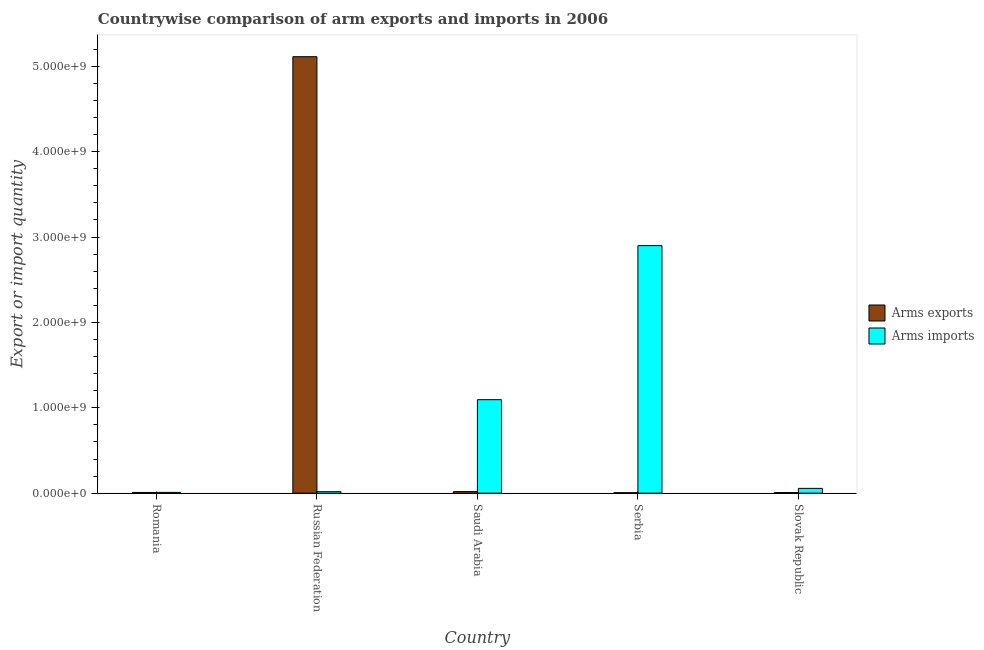How many different coloured bars are there?
Your response must be concise. 2. Are the number of bars on each tick of the X-axis equal?
Make the answer very short. Yes. How many bars are there on the 3rd tick from the left?
Provide a short and direct response. 2. What is the label of the 1st group of bars from the left?
Ensure brevity in your answer.  Romania. What is the arms imports in Serbia?
Provide a succinct answer. 2.90e+09. Across all countries, what is the maximum arms imports?
Give a very brief answer. 2.90e+09. Across all countries, what is the minimum arms exports?
Ensure brevity in your answer.  5.00e+06. In which country was the arms imports maximum?
Your answer should be compact. Serbia. In which country was the arms exports minimum?
Your response must be concise. Serbia. What is the total arms imports in the graph?
Your answer should be compact. 4.08e+09. What is the difference between the arms exports in Romania and that in Russian Federation?
Your answer should be compact. -5.10e+09. What is the difference between the arms exports in Romania and the arms imports in Russian Federation?
Provide a short and direct response. -9.00e+06. What is the average arms imports per country?
Keep it short and to the point. 8.15e+08. What is the difference between the arms exports and arms imports in Slovak Republic?
Provide a short and direct response. -4.90e+07. In how many countries, is the arms imports greater than 400000000 ?
Your answer should be compact. 2. What is the ratio of the arms imports in Serbia to that in Slovak Republic?
Your answer should be compact. 51.79. What is the difference between the highest and the second highest arms imports?
Offer a terse response. 1.80e+09. What is the difference between the highest and the lowest arms imports?
Your response must be concise. 2.89e+09. In how many countries, is the arms imports greater than the average arms imports taken over all countries?
Ensure brevity in your answer.  2. Is the sum of the arms exports in Romania and Slovak Republic greater than the maximum arms imports across all countries?
Give a very brief answer. No. What does the 1st bar from the left in Serbia represents?
Offer a terse response. Arms exports. What does the 2nd bar from the right in Romania represents?
Your answer should be compact. Arms exports. How many bars are there?
Offer a terse response. 10. How many countries are there in the graph?
Give a very brief answer. 5. What is the difference between two consecutive major ticks on the Y-axis?
Your answer should be compact. 1.00e+09. Where does the legend appear in the graph?
Give a very brief answer. Center right. How many legend labels are there?
Provide a succinct answer. 2. How are the legend labels stacked?
Provide a short and direct response. Vertical. What is the title of the graph?
Make the answer very short. Countrywise comparison of arm exports and imports in 2006. What is the label or title of the X-axis?
Provide a short and direct response. Country. What is the label or title of the Y-axis?
Offer a terse response. Export or import quantity. What is the Export or import quantity in Arms imports in Romania?
Keep it short and to the point. 9.00e+06. What is the Export or import quantity of Arms exports in Russian Federation?
Provide a short and direct response. 5.11e+09. What is the Export or import quantity of Arms imports in Russian Federation?
Offer a very short reply. 1.70e+07. What is the Export or import quantity in Arms exports in Saudi Arabia?
Offer a very short reply. 1.80e+07. What is the Export or import quantity in Arms imports in Saudi Arabia?
Give a very brief answer. 1.10e+09. What is the Export or import quantity of Arms imports in Serbia?
Offer a very short reply. 2.90e+09. What is the Export or import quantity of Arms exports in Slovak Republic?
Your response must be concise. 7.00e+06. What is the Export or import quantity of Arms imports in Slovak Republic?
Provide a short and direct response. 5.60e+07. Across all countries, what is the maximum Export or import quantity of Arms exports?
Provide a short and direct response. 5.11e+09. Across all countries, what is the maximum Export or import quantity in Arms imports?
Your answer should be very brief. 2.90e+09. Across all countries, what is the minimum Export or import quantity of Arms imports?
Offer a terse response. 9.00e+06. What is the total Export or import quantity of Arms exports in the graph?
Keep it short and to the point. 5.15e+09. What is the total Export or import quantity of Arms imports in the graph?
Your answer should be compact. 4.08e+09. What is the difference between the Export or import quantity in Arms exports in Romania and that in Russian Federation?
Provide a short and direct response. -5.10e+09. What is the difference between the Export or import quantity of Arms imports in Romania and that in Russian Federation?
Your answer should be compact. -8.00e+06. What is the difference between the Export or import quantity of Arms exports in Romania and that in Saudi Arabia?
Ensure brevity in your answer.  -1.00e+07. What is the difference between the Export or import quantity in Arms imports in Romania and that in Saudi Arabia?
Your answer should be very brief. -1.09e+09. What is the difference between the Export or import quantity in Arms exports in Romania and that in Serbia?
Offer a very short reply. 3.00e+06. What is the difference between the Export or import quantity of Arms imports in Romania and that in Serbia?
Your response must be concise. -2.89e+09. What is the difference between the Export or import quantity in Arms imports in Romania and that in Slovak Republic?
Your answer should be very brief. -4.70e+07. What is the difference between the Export or import quantity in Arms exports in Russian Federation and that in Saudi Arabia?
Ensure brevity in your answer.  5.10e+09. What is the difference between the Export or import quantity of Arms imports in Russian Federation and that in Saudi Arabia?
Provide a succinct answer. -1.08e+09. What is the difference between the Export or import quantity in Arms exports in Russian Federation and that in Serbia?
Provide a succinct answer. 5.11e+09. What is the difference between the Export or import quantity in Arms imports in Russian Federation and that in Serbia?
Ensure brevity in your answer.  -2.88e+09. What is the difference between the Export or import quantity of Arms exports in Russian Federation and that in Slovak Republic?
Provide a succinct answer. 5.11e+09. What is the difference between the Export or import quantity in Arms imports in Russian Federation and that in Slovak Republic?
Offer a very short reply. -3.90e+07. What is the difference between the Export or import quantity in Arms exports in Saudi Arabia and that in Serbia?
Provide a succinct answer. 1.30e+07. What is the difference between the Export or import quantity of Arms imports in Saudi Arabia and that in Serbia?
Make the answer very short. -1.80e+09. What is the difference between the Export or import quantity in Arms exports in Saudi Arabia and that in Slovak Republic?
Your response must be concise. 1.10e+07. What is the difference between the Export or import quantity in Arms imports in Saudi Arabia and that in Slovak Republic?
Ensure brevity in your answer.  1.04e+09. What is the difference between the Export or import quantity of Arms exports in Serbia and that in Slovak Republic?
Make the answer very short. -2.00e+06. What is the difference between the Export or import quantity in Arms imports in Serbia and that in Slovak Republic?
Provide a short and direct response. 2.84e+09. What is the difference between the Export or import quantity of Arms exports in Romania and the Export or import quantity of Arms imports in Russian Federation?
Your answer should be very brief. -9.00e+06. What is the difference between the Export or import quantity of Arms exports in Romania and the Export or import quantity of Arms imports in Saudi Arabia?
Give a very brief answer. -1.09e+09. What is the difference between the Export or import quantity of Arms exports in Romania and the Export or import quantity of Arms imports in Serbia?
Provide a succinct answer. -2.89e+09. What is the difference between the Export or import quantity of Arms exports in Romania and the Export or import quantity of Arms imports in Slovak Republic?
Provide a succinct answer. -4.80e+07. What is the difference between the Export or import quantity of Arms exports in Russian Federation and the Export or import quantity of Arms imports in Saudi Arabia?
Provide a succinct answer. 4.02e+09. What is the difference between the Export or import quantity in Arms exports in Russian Federation and the Export or import quantity in Arms imports in Serbia?
Give a very brief answer. 2.21e+09. What is the difference between the Export or import quantity in Arms exports in Russian Federation and the Export or import quantity in Arms imports in Slovak Republic?
Make the answer very short. 5.06e+09. What is the difference between the Export or import quantity of Arms exports in Saudi Arabia and the Export or import quantity of Arms imports in Serbia?
Your answer should be very brief. -2.88e+09. What is the difference between the Export or import quantity in Arms exports in Saudi Arabia and the Export or import quantity in Arms imports in Slovak Republic?
Provide a succinct answer. -3.80e+07. What is the difference between the Export or import quantity of Arms exports in Serbia and the Export or import quantity of Arms imports in Slovak Republic?
Make the answer very short. -5.10e+07. What is the average Export or import quantity of Arms exports per country?
Give a very brief answer. 1.03e+09. What is the average Export or import quantity of Arms imports per country?
Offer a terse response. 8.15e+08. What is the difference between the Export or import quantity in Arms exports and Export or import quantity in Arms imports in Romania?
Ensure brevity in your answer.  -1.00e+06. What is the difference between the Export or import quantity of Arms exports and Export or import quantity of Arms imports in Russian Federation?
Give a very brief answer. 5.10e+09. What is the difference between the Export or import quantity in Arms exports and Export or import quantity in Arms imports in Saudi Arabia?
Make the answer very short. -1.08e+09. What is the difference between the Export or import quantity in Arms exports and Export or import quantity in Arms imports in Serbia?
Give a very brief answer. -2.90e+09. What is the difference between the Export or import quantity in Arms exports and Export or import quantity in Arms imports in Slovak Republic?
Your answer should be very brief. -4.90e+07. What is the ratio of the Export or import quantity in Arms exports in Romania to that in Russian Federation?
Offer a terse response. 0. What is the ratio of the Export or import quantity of Arms imports in Romania to that in Russian Federation?
Your answer should be very brief. 0.53. What is the ratio of the Export or import quantity of Arms exports in Romania to that in Saudi Arabia?
Ensure brevity in your answer.  0.44. What is the ratio of the Export or import quantity in Arms imports in Romania to that in Saudi Arabia?
Give a very brief answer. 0.01. What is the ratio of the Export or import quantity in Arms imports in Romania to that in Serbia?
Provide a short and direct response. 0. What is the ratio of the Export or import quantity in Arms imports in Romania to that in Slovak Republic?
Ensure brevity in your answer.  0.16. What is the ratio of the Export or import quantity of Arms exports in Russian Federation to that in Saudi Arabia?
Provide a short and direct response. 284.06. What is the ratio of the Export or import quantity of Arms imports in Russian Federation to that in Saudi Arabia?
Offer a very short reply. 0.02. What is the ratio of the Export or import quantity of Arms exports in Russian Federation to that in Serbia?
Offer a terse response. 1022.6. What is the ratio of the Export or import quantity of Arms imports in Russian Federation to that in Serbia?
Provide a succinct answer. 0.01. What is the ratio of the Export or import quantity of Arms exports in Russian Federation to that in Slovak Republic?
Ensure brevity in your answer.  730.43. What is the ratio of the Export or import quantity in Arms imports in Russian Federation to that in Slovak Republic?
Offer a terse response. 0.3. What is the ratio of the Export or import quantity in Arms exports in Saudi Arabia to that in Serbia?
Your response must be concise. 3.6. What is the ratio of the Export or import quantity of Arms imports in Saudi Arabia to that in Serbia?
Provide a succinct answer. 0.38. What is the ratio of the Export or import quantity of Arms exports in Saudi Arabia to that in Slovak Republic?
Provide a succinct answer. 2.57. What is the ratio of the Export or import quantity of Arms imports in Saudi Arabia to that in Slovak Republic?
Your response must be concise. 19.55. What is the ratio of the Export or import quantity of Arms imports in Serbia to that in Slovak Republic?
Provide a short and direct response. 51.79. What is the difference between the highest and the second highest Export or import quantity in Arms exports?
Offer a terse response. 5.10e+09. What is the difference between the highest and the second highest Export or import quantity in Arms imports?
Your response must be concise. 1.80e+09. What is the difference between the highest and the lowest Export or import quantity of Arms exports?
Give a very brief answer. 5.11e+09. What is the difference between the highest and the lowest Export or import quantity in Arms imports?
Your response must be concise. 2.89e+09. 